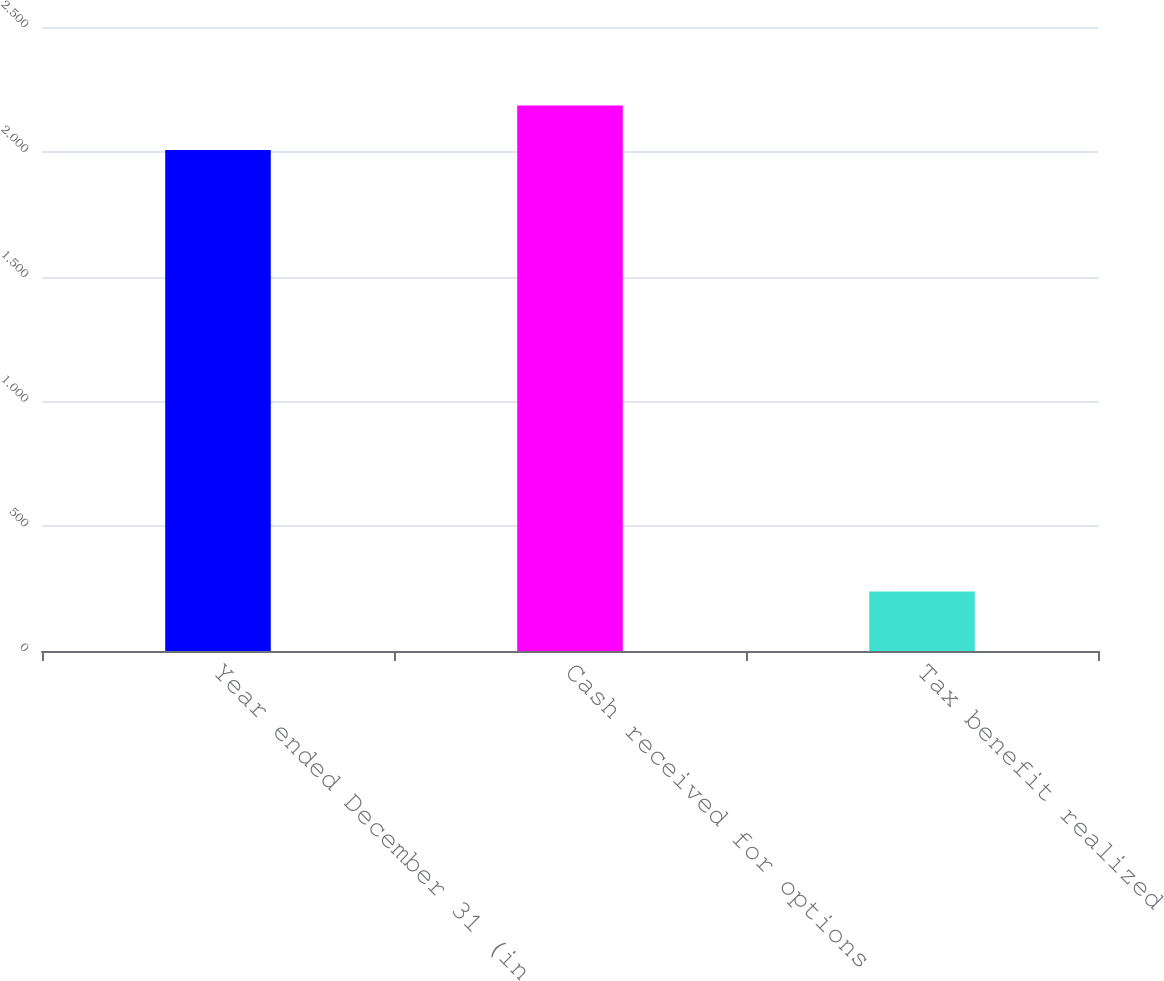<chart> <loc_0><loc_0><loc_500><loc_500><bar_chart><fcel>Year ended December 31 (in<fcel>Cash received for options<fcel>Tax benefit realized<nl><fcel>2007<fcel>2185.5<fcel>238<nl></chart> 